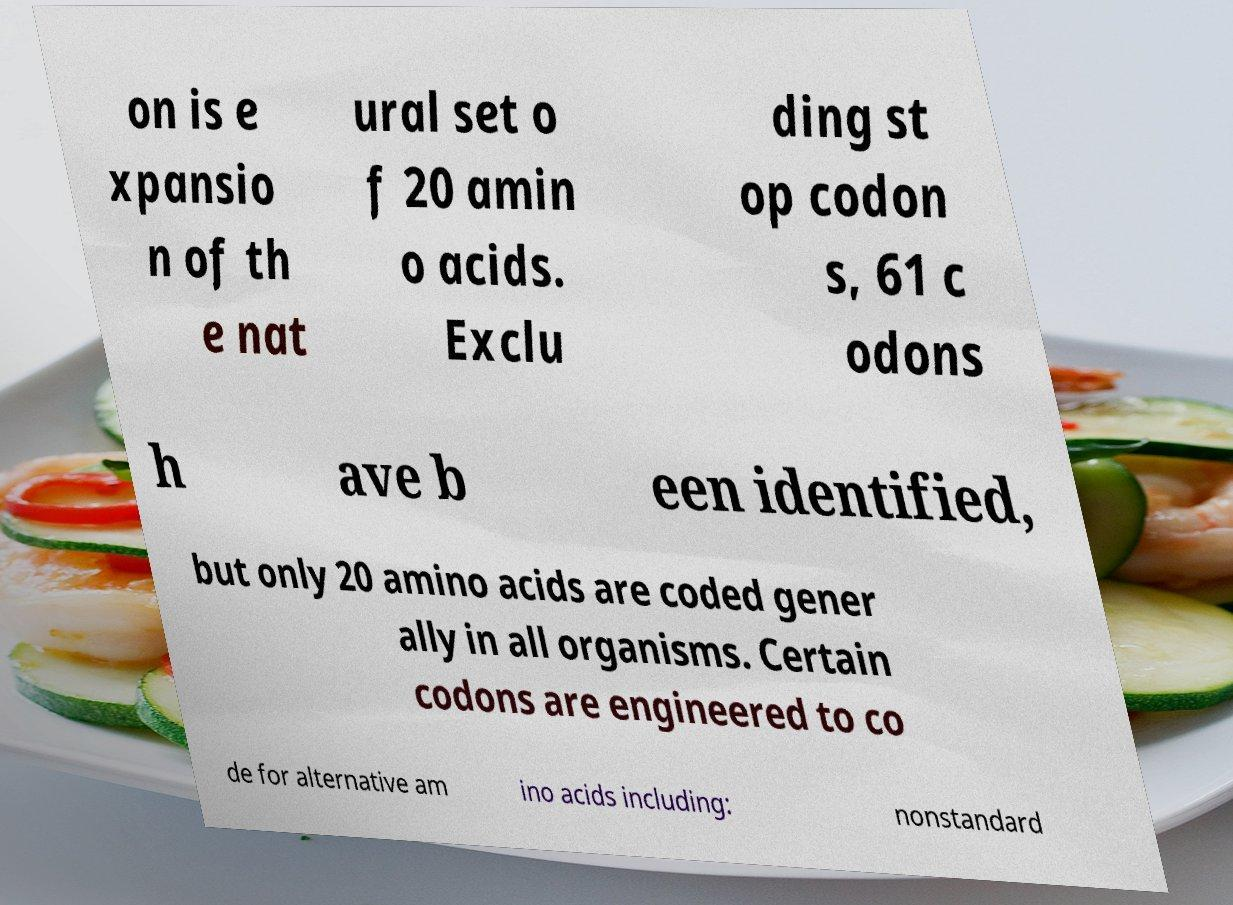What messages or text are displayed in this image? I need them in a readable, typed format. on is e xpansio n of th e nat ural set o f 20 amin o acids. Exclu ding st op codon s, 61 c odons h ave b een identified, but only 20 amino acids are coded gener ally in all organisms. Certain codons are engineered to co de for alternative am ino acids including: nonstandard 